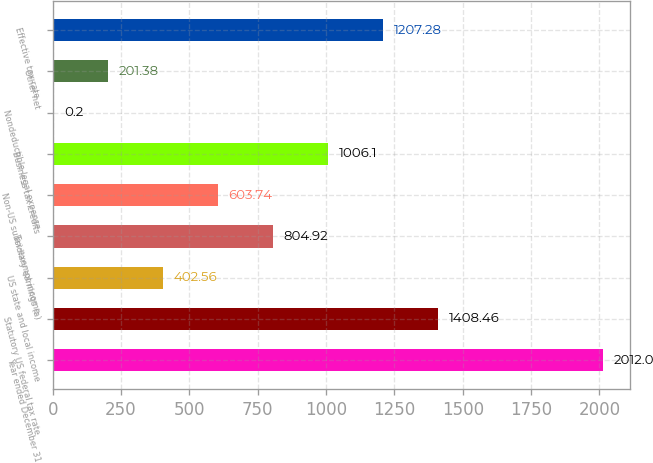<chart> <loc_0><loc_0><loc_500><loc_500><bar_chart><fcel>Year ended December 31<fcel>Statutory US federal tax rate<fcel>US state and local income<fcel>Tax-exempt income<fcel>Non-US subsidiary earnings (a)<fcel>Business tax credits<fcel>Nondeductible legal expense<fcel>Other net<fcel>Effective tax rate<nl><fcel>2012<fcel>1408.46<fcel>402.56<fcel>804.92<fcel>603.74<fcel>1006.1<fcel>0.2<fcel>201.38<fcel>1207.28<nl></chart> 